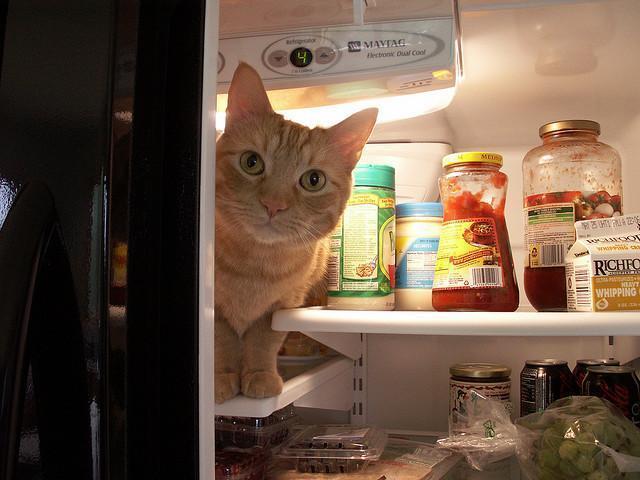How many bottles are visible?
Give a very brief answer. 4. How many refrigerators are there?
Give a very brief answer. 2. 